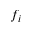<formula> <loc_0><loc_0><loc_500><loc_500>f _ { i }</formula> 